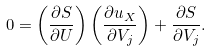Convert formula to latex. <formula><loc_0><loc_0><loc_500><loc_500>0 = \left ( \frac { \partial S } { \partial U } \right ) \left ( \frac { \partial u _ { X } } { \partial V _ { j } } \right ) + \frac { \partial S } { \partial V _ { j } } .</formula> 